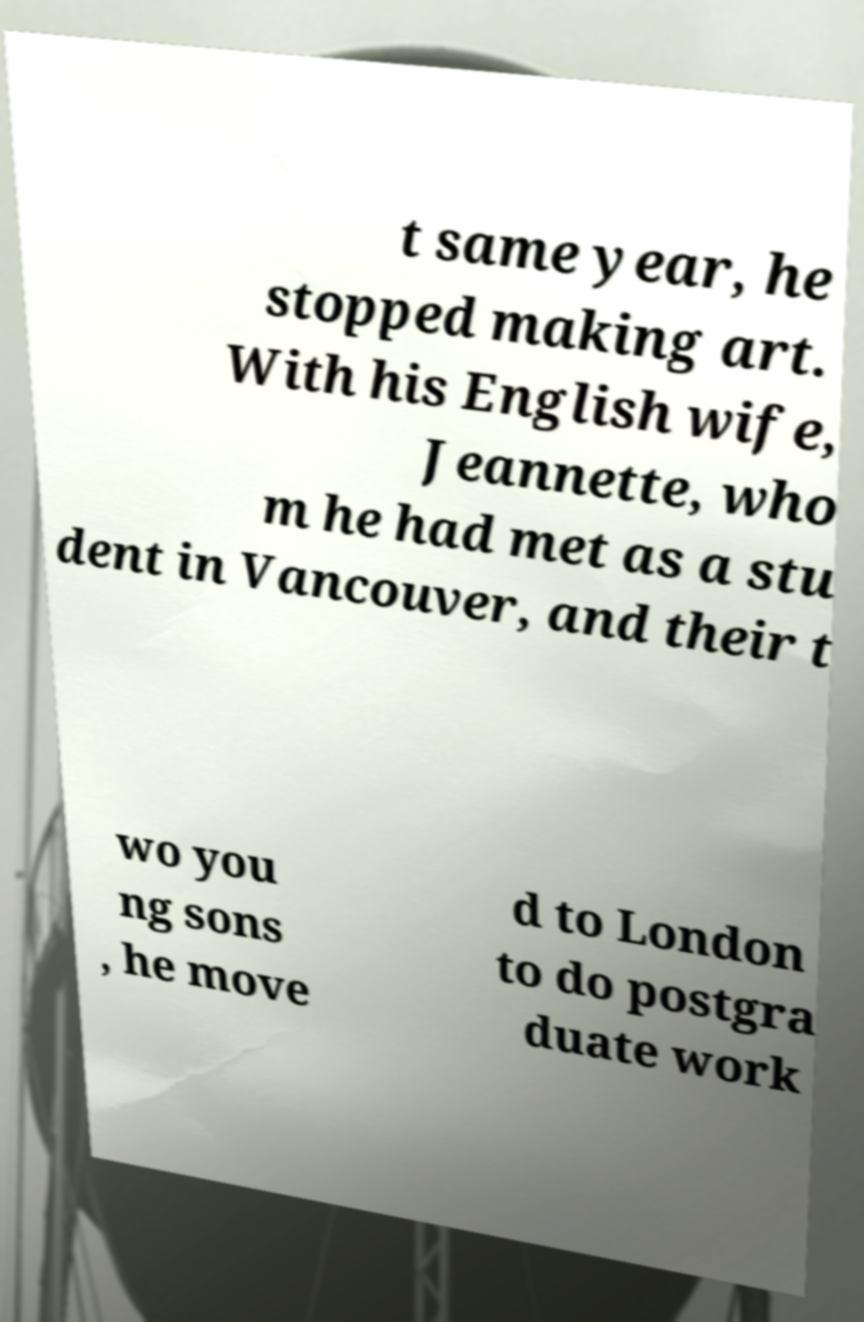Could you assist in decoding the text presented in this image and type it out clearly? t same year, he stopped making art. With his English wife, Jeannette, who m he had met as a stu dent in Vancouver, and their t wo you ng sons , he move d to London to do postgra duate work 